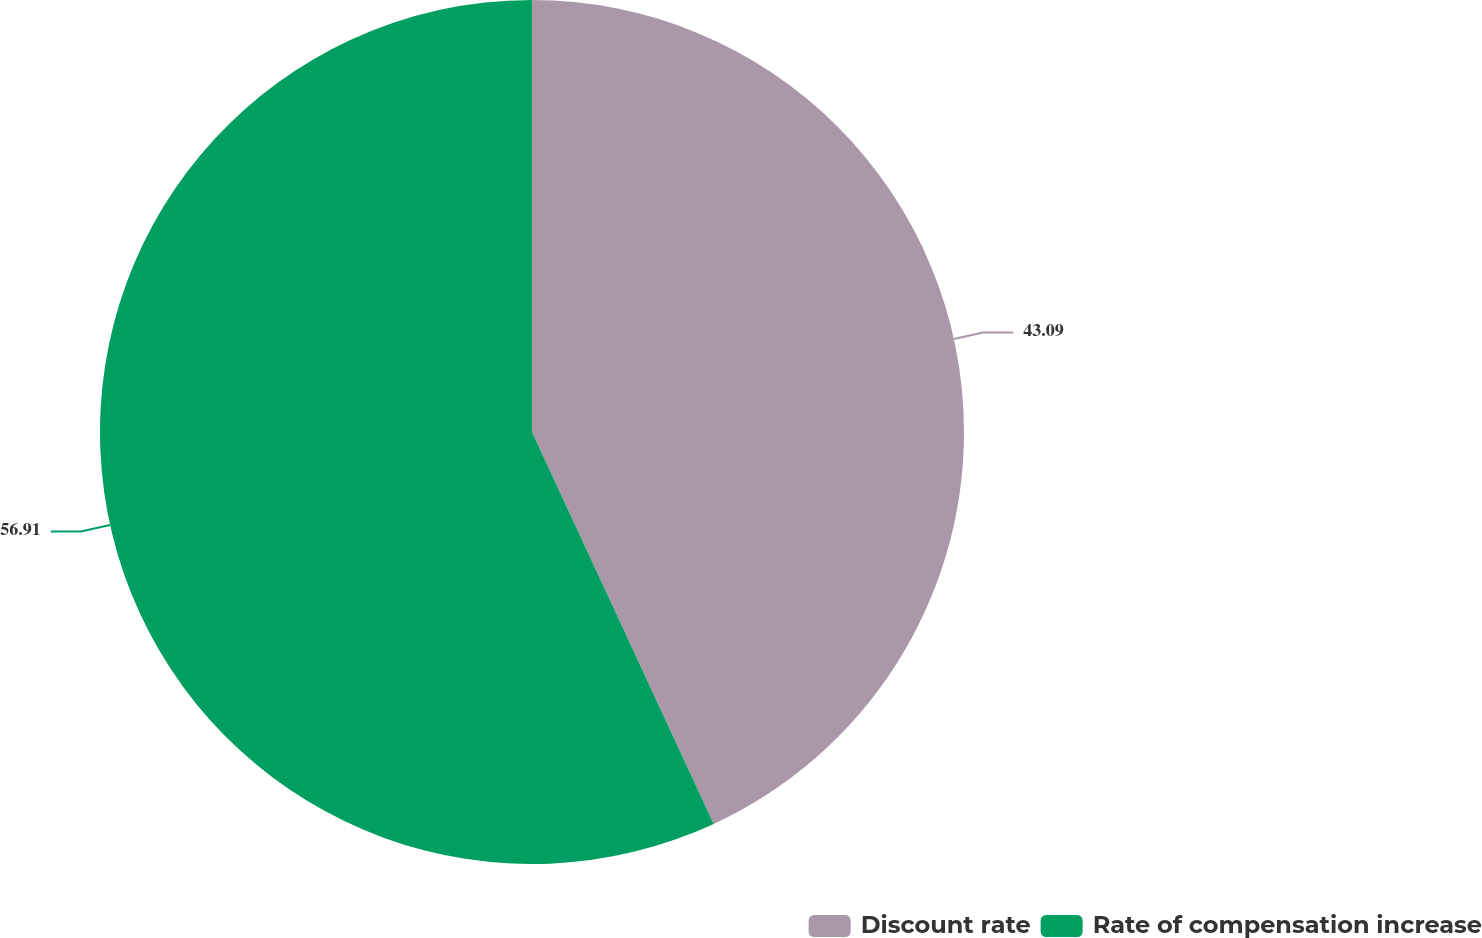Convert chart to OTSL. <chart><loc_0><loc_0><loc_500><loc_500><pie_chart><fcel>Discount rate<fcel>Rate of compensation increase<nl><fcel>43.09%<fcel>56.91%<nl></chart> 